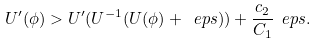<formula> <loc_0><loc_0><loc_500><loc_500>U ^ { \prime } ( \phi ) > U ^ { \prime } ( U ^ { - 1 } ( U ( \phi ) + \ e p s ) ) + \frac { c _ { 2 } } { C _ { 1 } } \ e p s .</formula> 